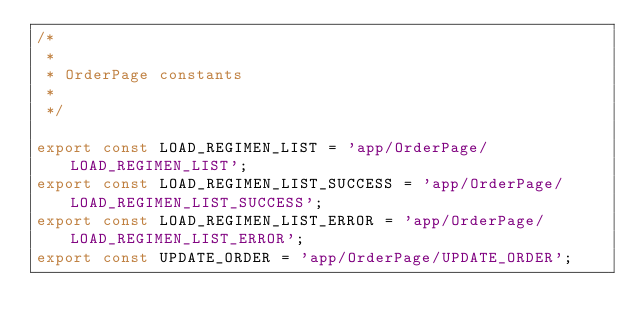Convert code to text. <code><loc_0><loc_0><loc_500><loc_500><_JavaScript_>/*
 *
 * OrderPage constants
 *
 */

export const LOAD_REGIMEN_LIST = 'app/OrderPage/LOAD_REGIMEN_LIST';
export const LOAD_REGIMEN_LIST_SUCCESS = 'app/OrderPage/LOAD_REGIMEN_LIST_SUCCESS';
export const LOAD_REGIMEN_LIST_ERROR = 'app/OrderPage/LOAD_REGIMEN_LIST_ERROR';
export const UPDATE_ORDER = 'app/OrderPage/UPDATE_ORDER';
</code> 